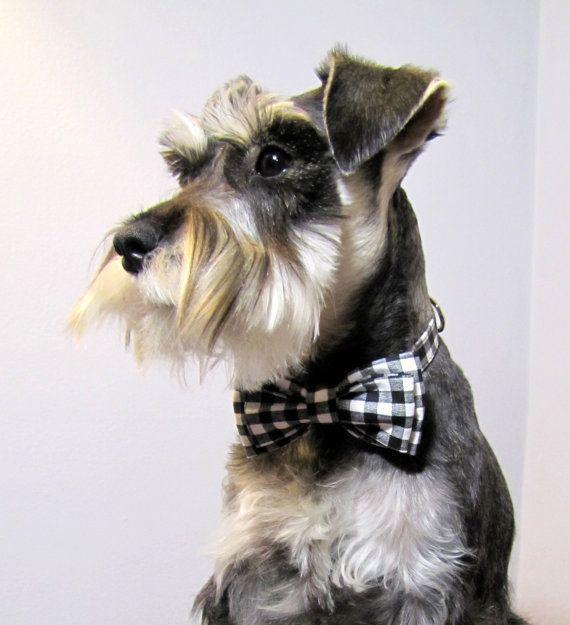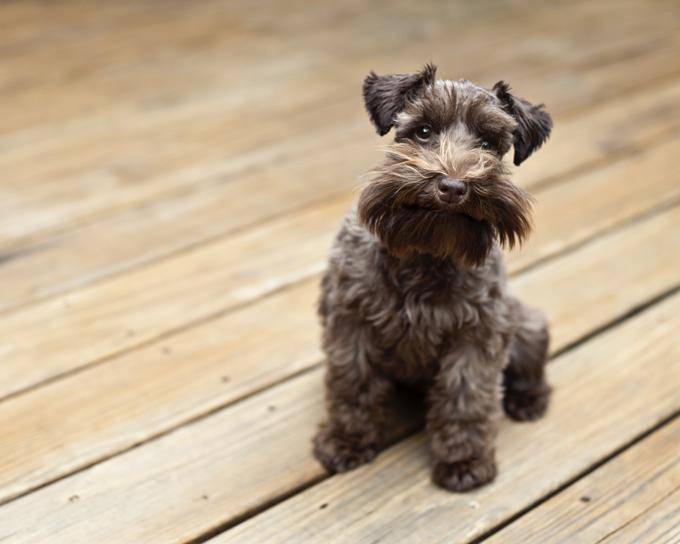The first image is the image on the left, the second image is the image on the right. Assess this claim about the two images: "An image shows a schnauzer posed on a wood plank floor.". Correct or not? Answer yes or no. Yes. The first image is the image on the left, the second image is the image on the right. Examine the images to the left and right. Is the description "A dog is sitting on wood floor." accurate? Answer yes or no. Yes. 